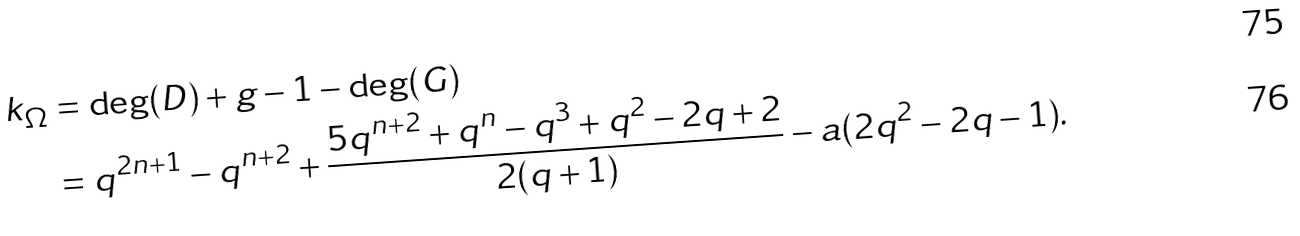<formula> <loc_0><loc_0><loc_500><loc_500>k _ { \Omega } & = \deg ( D ) + g - 1 - \deg ( G ) \\ & = q ^ { 2 n + 1 } - q ^ { n + 2 } + \frac { 5 q ^ { n + 2 } + q ^ { n } - q ^ { 3 } + q ^ { 2 } - 2 q + 2 } { 2 ( q + 1 ) } - a ( 2 q ^ { 2 } - 2 q - 1 ) .</formula> 